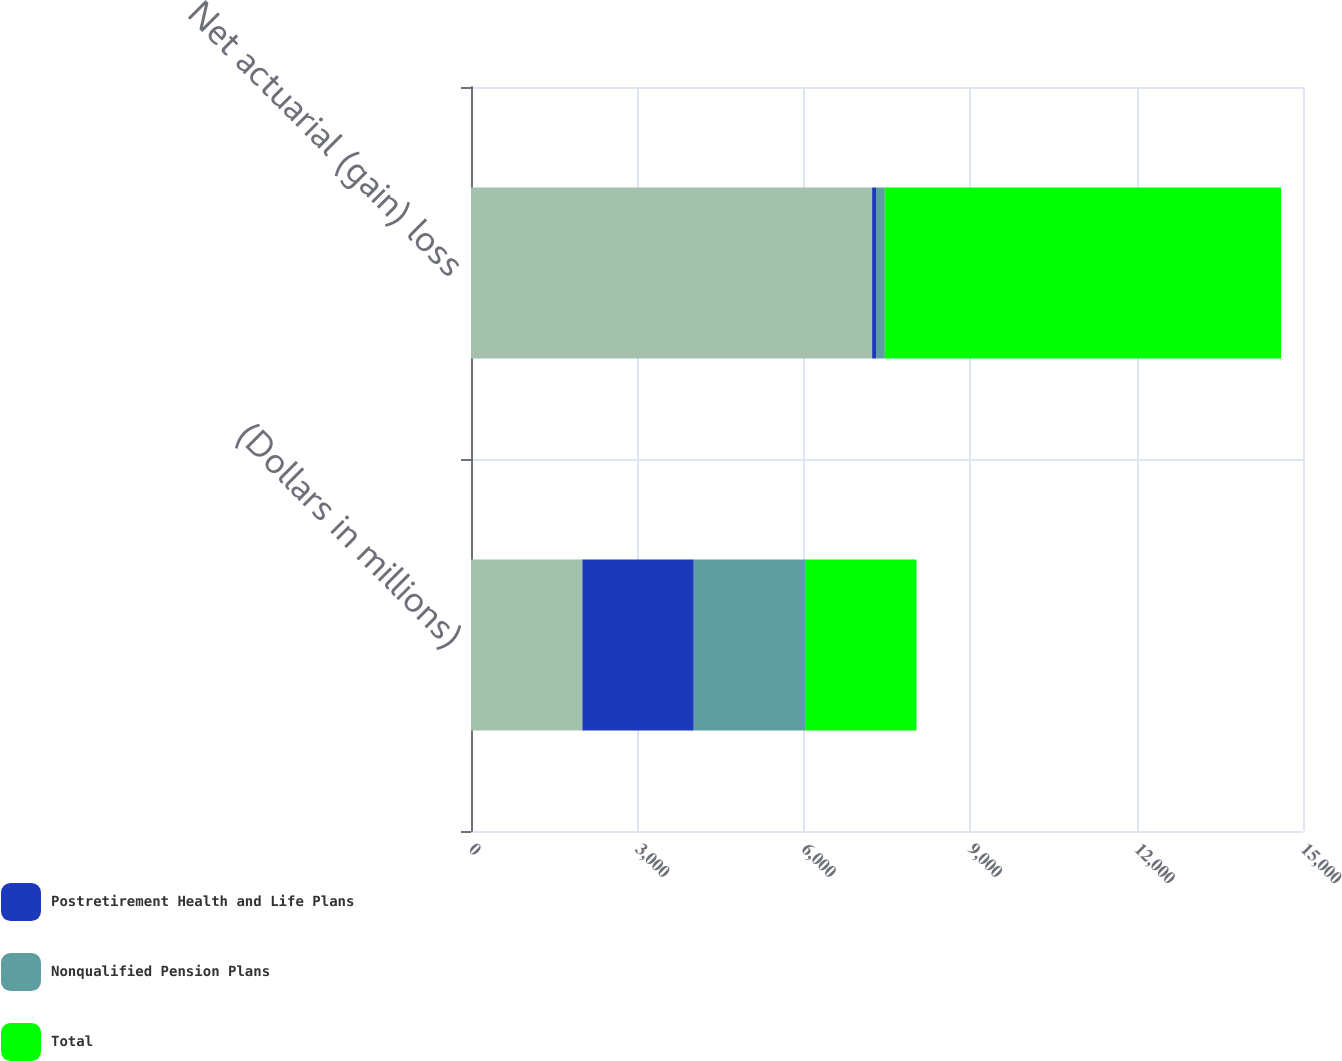<chart> <loc_0><loc_0><loc_500><loc_500><stacked_bar_chart><ecel><fcel>(Dollars in millions)<fcel>Net actuarial (gain) loss<nl><fcel>nan<fcel>2008<fcel>7232<nl><fcel>Postretirement Health and Life Plans<fcel>2008<fcel>70<nl><fcel>Nonqualified Pension Plans<fcel>2008<fcel>158<nl><fcel>Total<fcel>2008<fcel>7144<nl></chart> 